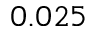Convert formula to latex. <formula><loc_0><loc_0><loc_500><loc_500>0 . 0 2 5</formula> 